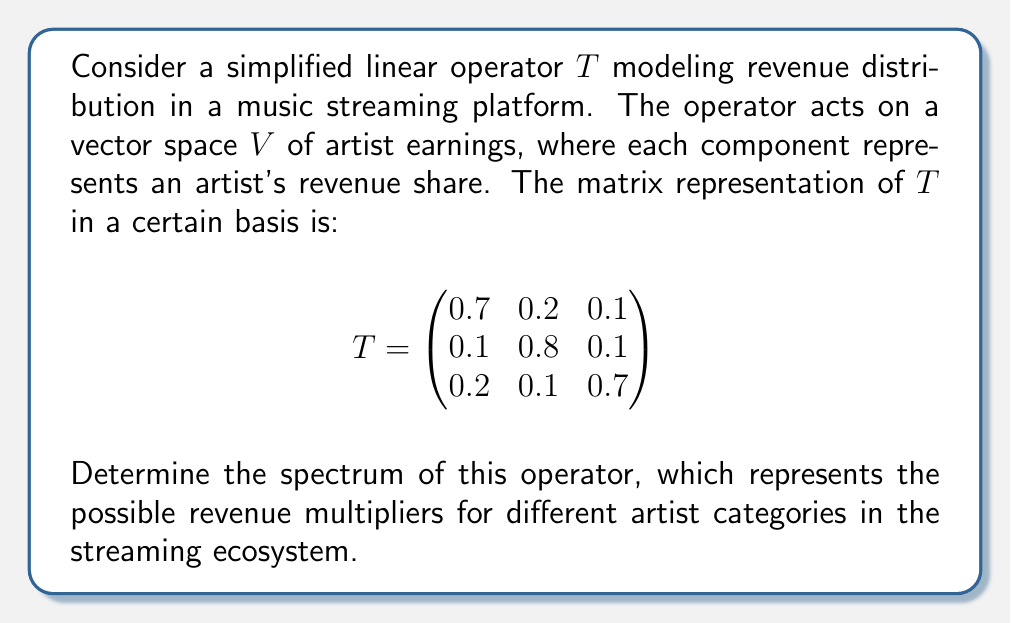Can you answer this question? To find the spectrum of the linear operator $T$, we need to determine its eigenvalues. The steps are as follows:

1) The characteristic polynomial of $T$ is given by $p(\lambda) = \det(T - \lambda I)$, where $I$ is the 3x3 identity matrix.

2) Expanding the determinant:

   $$p(\lambda) = \det\begin{pmatrix}
   0.7-\lambda & 0.2 & 0.1 \\
   0.1 & 0.8-\lambda & 0.1 \\
   0.2 & 0.1 & 0.7-\lambda
   \end{pmatrix}$$

3) Calculating the determinant:

   $p(\lambda) = (0.7-\lambda)(0.8-\lambda)(0.7-\lambda) - 0.1 \cdot 0.1 \cdot 0.2 - 0.1 \cdot 0.1 \cdot 0.2$
               $- 0.2 \cdot 0.1 \cdot 0.1 - 0.1 \cdot 0.2 \cdot 0.1 - 0.2 \cdot 0.1 \cdot 0.1$

4) Simplifying:

   $p(\lambda) = -\lambda^3 + 2.2\lambda^2 - 1.54\lambda + 0.34$

5) The roots of this polynomial are the eigenvalues of $T$. Using the cubic formula or numerical methods, we find the roots to be:

   $\lambda_1 = 1$
   $\lambda_2 = 0.6$
   $\lambda_3 = 0.6$

6) The spectrum of $T$ is the set of these eigenvalues.
Answer: $\{1, 0.6, 0.6\}$ 